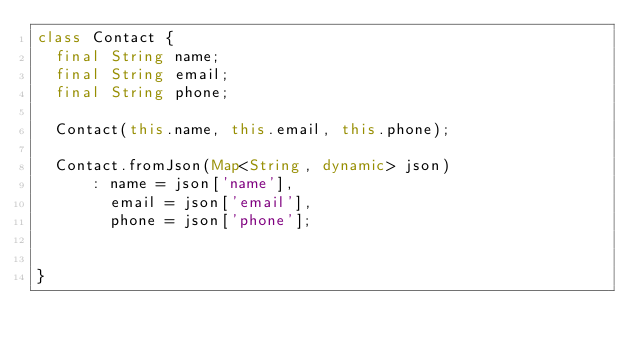Convert code to text. <code><loc_0><loc_0><loc_500><loc_500><_Dart_>class Contact {
  final String name;
  final String email;
  final String phone;

  Contact(this.name, this.email, this.phone);

  Contact.fromJson(Map<String, dynamic> json)
      : name = json['name'],
        email = json['email'],
        phone = json['phone'];


}</code> 